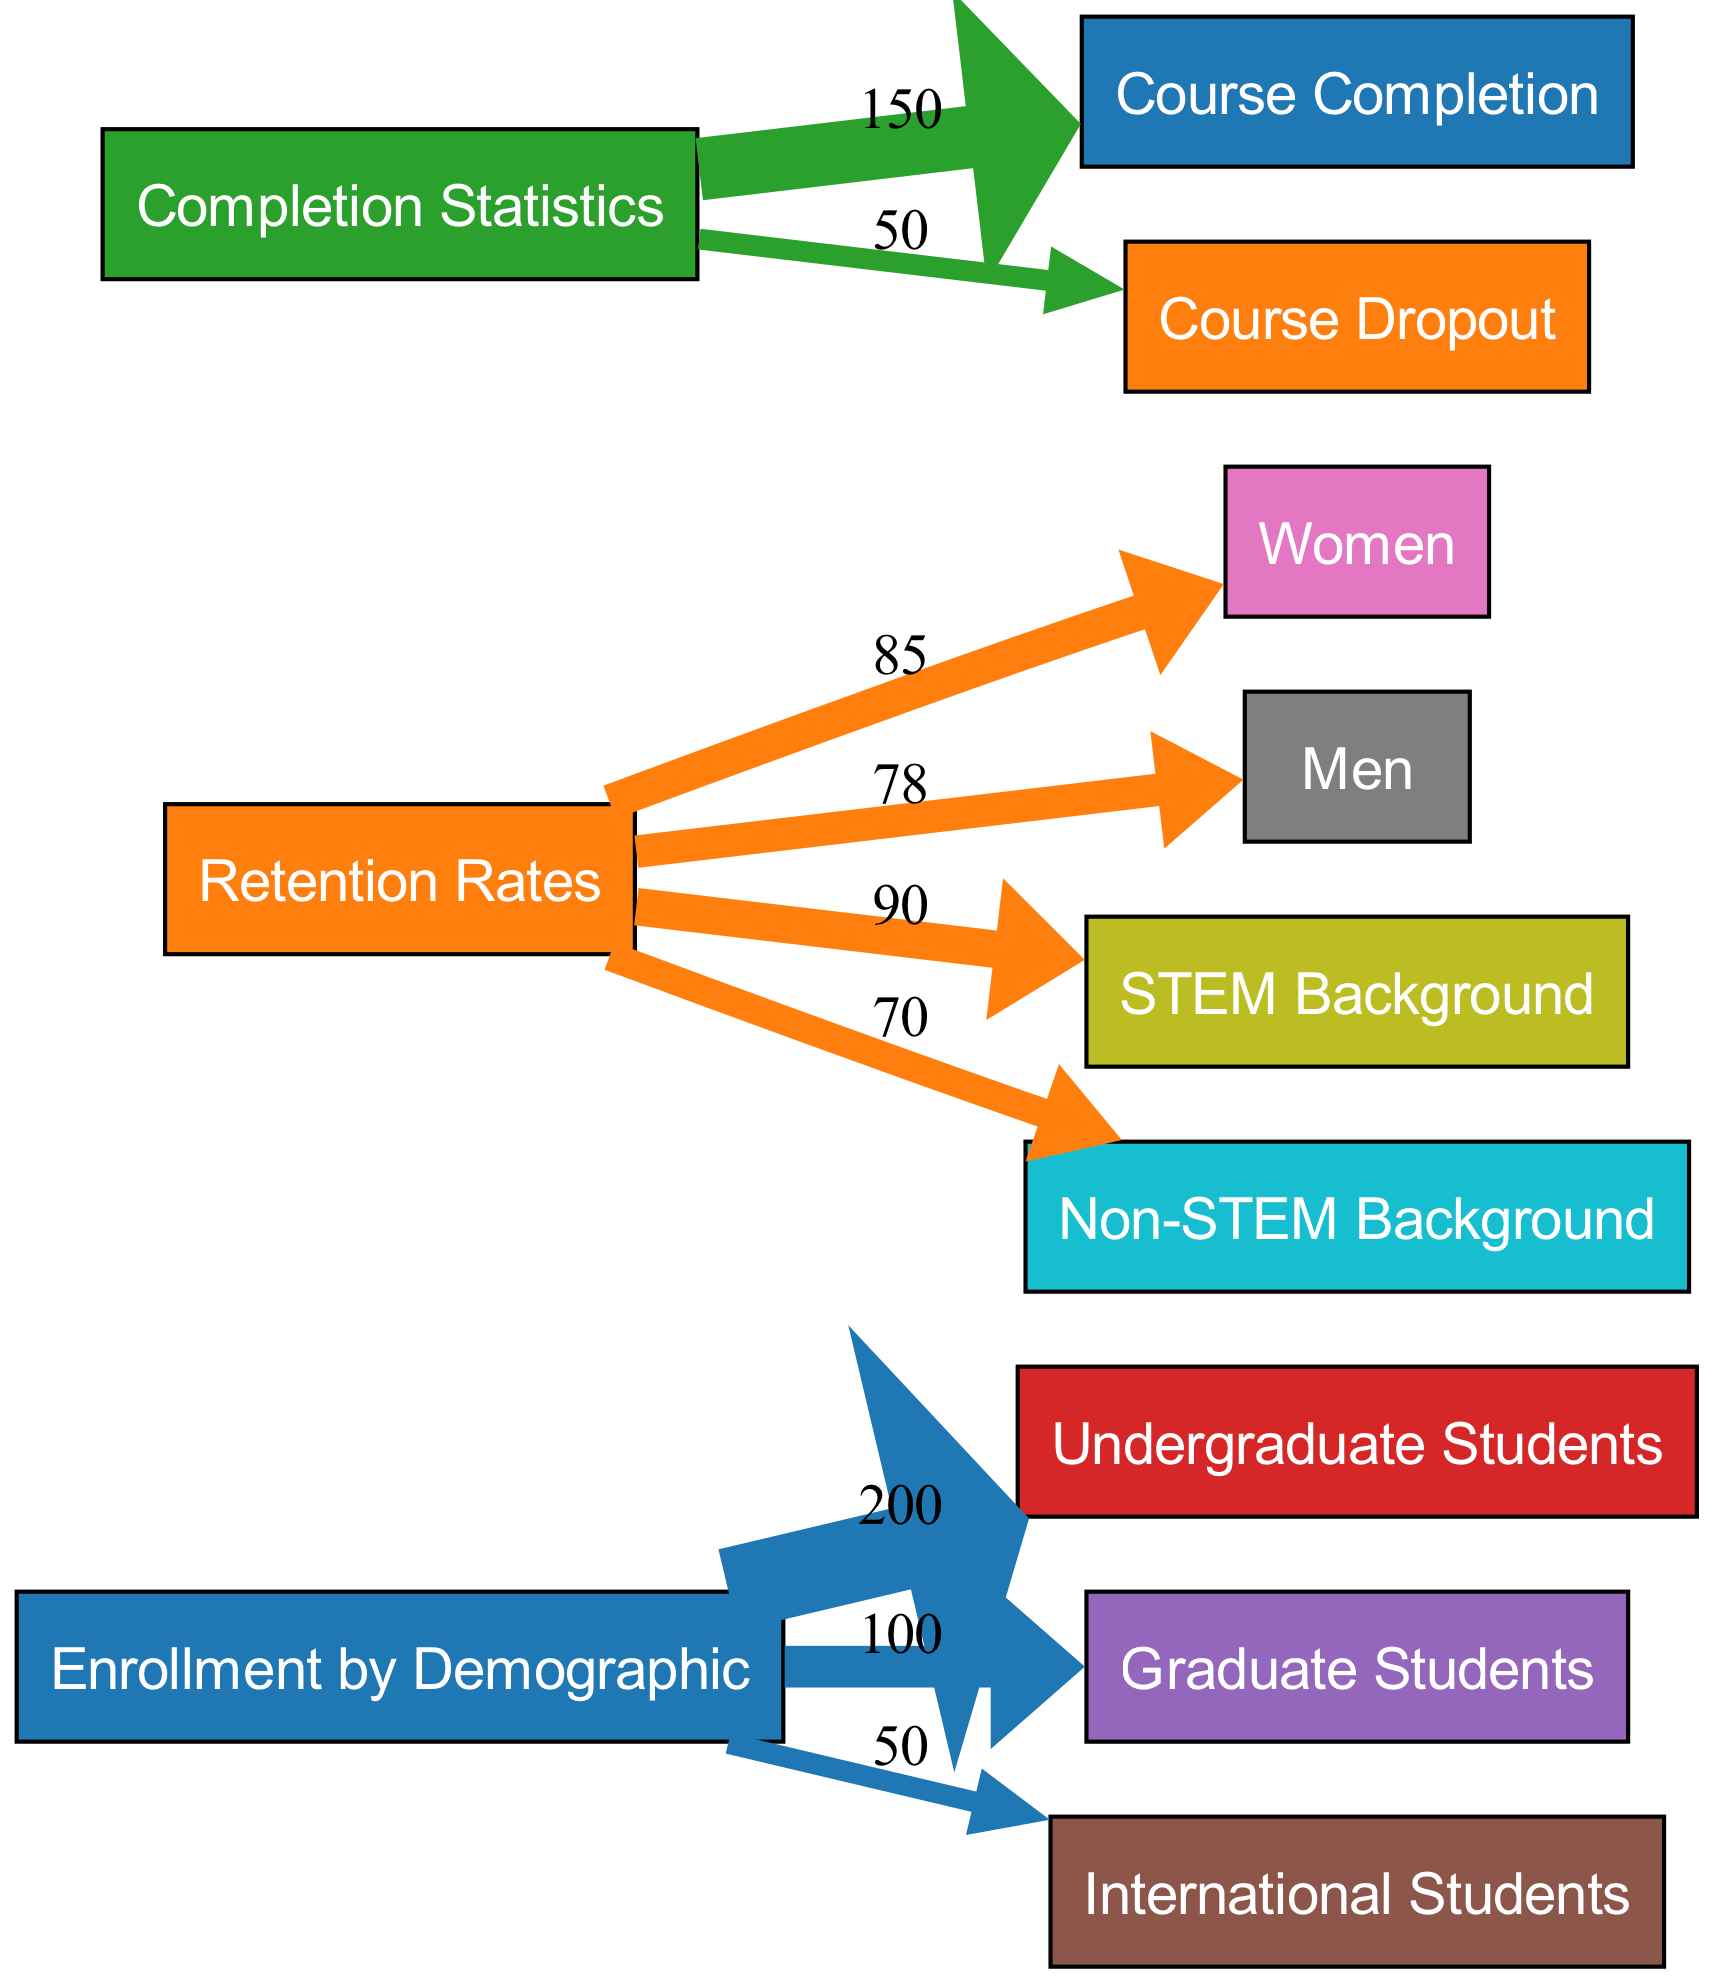What is the total number of nodes in the diagram? The diagram shows a total of 11 distinct nodes. They include three source nodes (Enrollment by Demographic, Retention Rates, Completion Statistics), five demographic nodes (Undergraduate Students, Graduate Students, International Students, Women, Men), two context nodes (STEM Background, Non-STEM Background), and two outcome nodes (Course Completion, Course Dropout).
Answer: 11 What is the retention rate for women? The value associated with the node for Women, which connects from Retention Rates, is 85. This directly corresponds to the retention statistic depicted in the diagram.
Answer: 85 How many enrolled undergraduate students are there? The node for Undergraduate Students shows a value of 200, which represents the count of students in that demographic gathered from the Enrollment by Demographic source.
Answer: 200 What percentage of STEM background students are retained? The retention rate linked from the Retention Rates node to the STEM Background node indicates a value of 90, representing the retention percentage for that demographic.
Answer: 90 What is the total number of course completions represented in the diagram? The sum of the value of Course Completion, which is 150, shows the count of students that completed their courses as depicted from the Completion Statistics source.
Answer: 150 Which demographic has the highest retention rate? Comparing retention rates linked from Retention Rates, Women at 85 has a higher value than Men at 78 and Non-STEM Background at 70. Therefore, Women have the highest retention rate.
Answer: Women How many more students completed their courses than dropped out? The diagram shows that Course Completion is 150 and Course Dropout is 50. Subtracting the latter from the former (150 - 50) gives us the net difference in numbers.
Answer: 100 What is the value for international students enrolling? The value for International Students from the Enrollment by Demographic node is 50, indicating the number of international students enrolled in the astrophysics courses.
Answer: 50 What demographic comprises the lowest number of students enrolled? Among the demographics, the International Students node with a value of 50 suggests it has the lowest enrollment when compared to Undergraduate Students (200) and Graduate Students (100).
Answer: International Students 